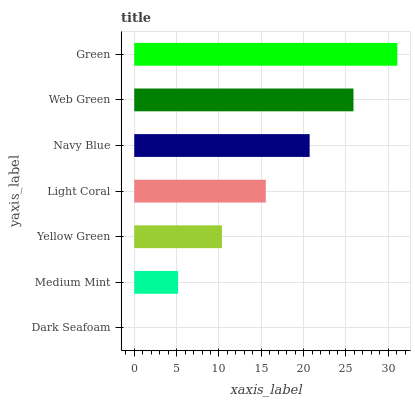Is Dark Seafoam the minimum?
Answer yes or no. Yes. Is Green the maximum?
Answer yes or no. Yes. Is Medium Mint the minimum?
Answer yes or no. No. Is Medium Mint the maximum?
Answer yes or no. No. Is Medium Mint greater than Dark Seafoam?
Answer yes or no. Yes. Is Dark Seafoam less than Medium Mint?
Answer yes or no. Yes. Is Dark Seafoam greater than Medium Mint?
Answer yes or no. No. Is Medium Mint less than Dark Seafoam?
Answer yes or no. No. Is Light Coral the high median?
Answer yes or no. Yes. Is Light Coral the low median?
Answer yes or no. Yes. Is Dark Seafoam the high median?
Answer yes or no. No. Is Dark Seafoam the low median?
Answer yes or no. No. 